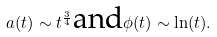<formula> <loc_0><loc_0><loc_500><loc_500>a ( t ) \sim t ^ { \frac { 3 } { 4 } } \text {and} \phi ( t ) \sim \ln ( t ) .</formula> 